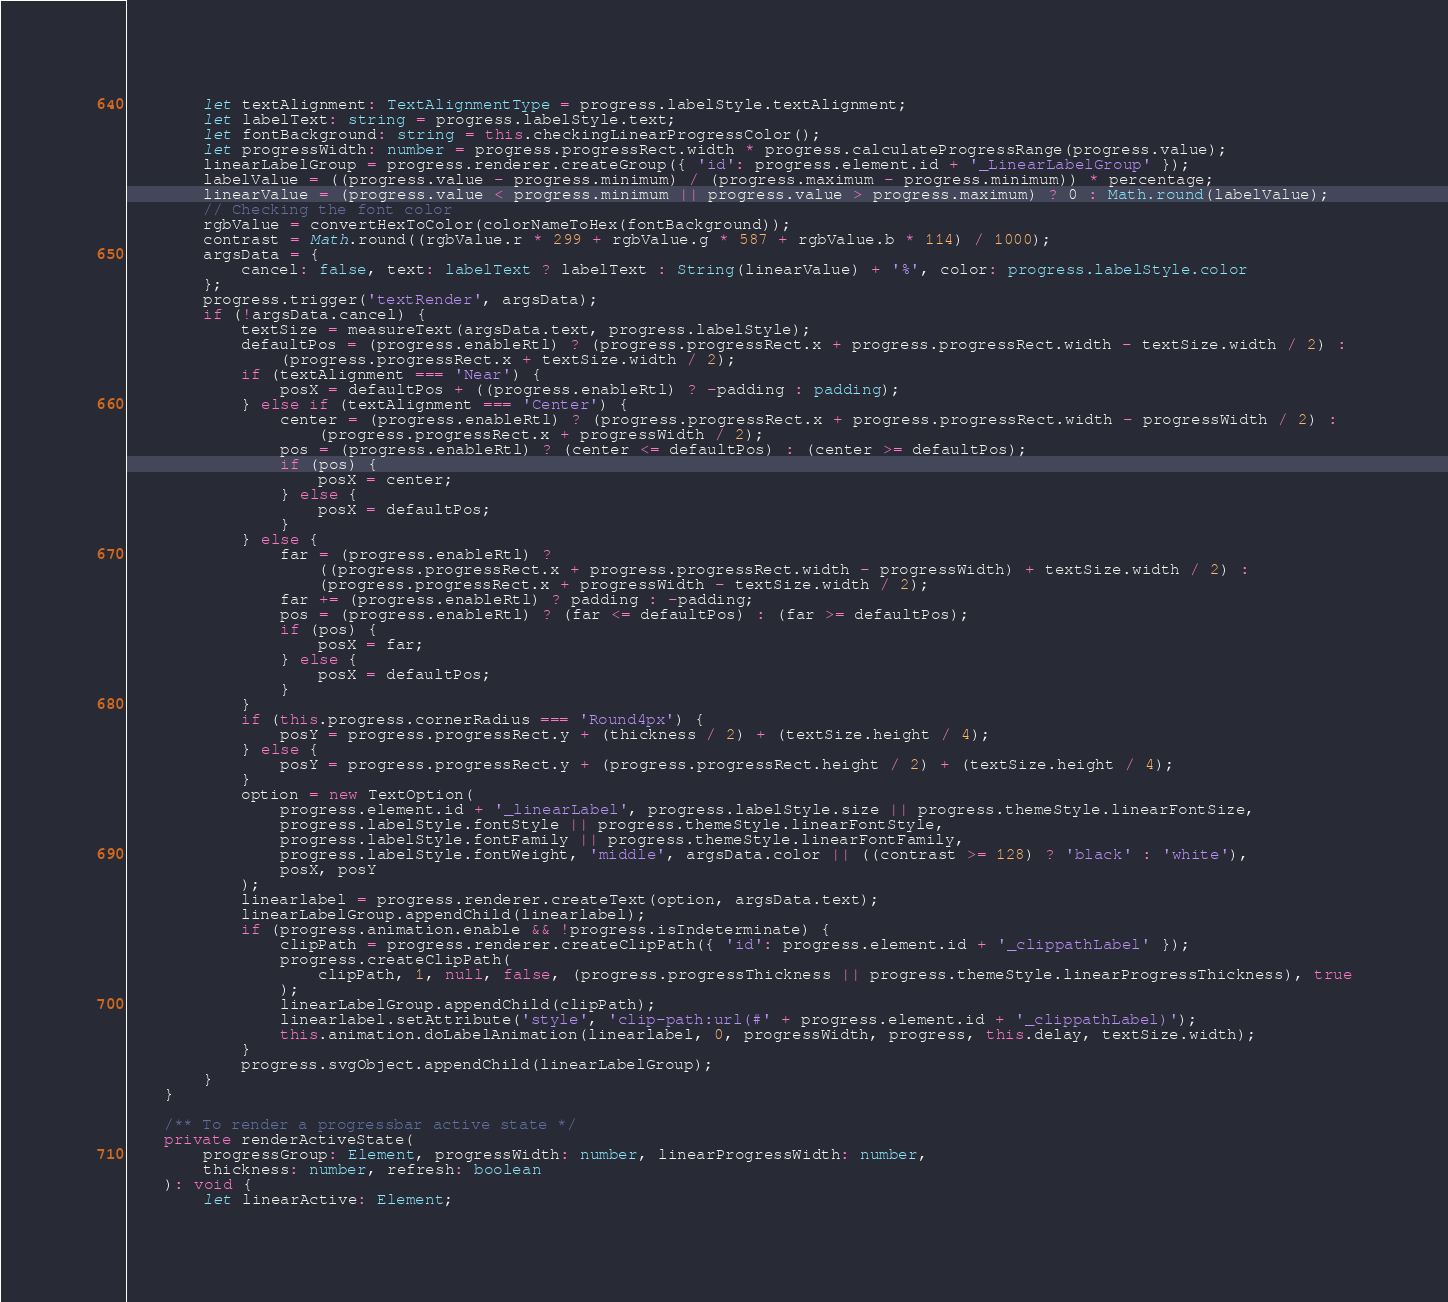Convert code to text. <code><loc_0><loc_0><loc_500><loc_500><_TypeScript_>        let textAlignment: TextAlignmentType = progress.labelStyle.textAlignment;
        let labelText: string = progress.labelStyle.text;
        let fontBackground: string = this.checkingLinearProgressColor();
        let progressWidth: number = progress.progressRect.width * progress.calculateProgressRange(progress.value);
        linearLabelGroup = progress.renderer.createGroup({ 'id': progress.element.id + '_LinearLabelGroup' });
        labelValue = ((progress.value - progress.minimum) / (progress.maximum - progress.minimum)) * percentage;
        linearValue = (progress.value < progress.minimum || progress.value > progress.maximum) ? 0 : Math.round(labelValue);
        // Checking the font color
        rgbValue = convertHexToColor(colorNameToHex(fontBackground));
        contrast = Math.round((rgbValue.r * 299 + rgbValue.g * 587 + rgbValue.b * 114) / 1000);
        argsData = {
            cancel: false, text: labelText ? labelText : String(linearValue) + '%', color: progress.labelStyle.color
        };
        progress.trigger('textRender', argsData);
        if (!argsData.cancel) {
            textSize = measureText(argsData.text, progress.labelStyle);
            defaultPos = (progress.enableRtl) ? (progress.progressRect.x + progress.progressRect.width - textSize.width / 2) :
                (progress.progressRect.x + textSize.width / 2);
            if (textAlignment === 'Near') {
                posX = defaultPos + ((progress.enableRtl) ? -padding : padding);
            } else if (textAlignment === 'Center') {
                center = (progress.enableRtl) ? (progress.progressRect.x + progress.progressRect.width - progressWidth / 2) :
                    (progress.progressRect.x + progressWidth / 2);
                pos = (progress.enableRtl) ? (center <= defaultPos) : (center >= defaultPos);
                if (pos) {
                    posX = center;
                } else {
                    posX = defaultPos;
                }
            } else {
                far = (progress.enableRtl) ?
                    ((progress.progressRect.x + progress.progressRect.width - progressWidth) + textSize.width / 2) :
                    (progress.progressRect.x + progressWidth - textSize.width / 2);
                far += (progress.enableRtl) ? padding : -padding;
                pos = (progress.enableRtl) ? (far <= defaultPos) : (far >= defaultPos);
                if (pos) {
                    posX = far;
                } else {
                    posX = defaultPos;
                }
            }
            if (this.progress.cornerRadius === 'Round4px') {
                posY = progress.progressRect.y + (thickness / 2) + (textSize.height / 4);
            } else {
                posY = progress.progressRect.y + (progress.progressRect.height / 2) + (textSize.height / 4);
            }
            option = new TextOption(
                progress.element.id + '_linearLabel', progress.labelStyle.size || progress.themeStyle.linearFontSize,
                progress.labelStyle.fontStyle || progress.themeStyle.linearFontStyle,
                progress.labelStyle.fontFamily || progress.themeStyle.linearFontFamily,
                progress.labelStyle.fontWeight, 'middle', argsData.color || ((contrast >= 128) ? 'black' : 'white'),
                posX, posY
            );
            linearlabel = progress.renderer.createText(option, argsData.text);
            linearLabelGroup.appendChild(linearlabel);
            if (progress.animation.enable && !progress.isIndeterminate) {
                clipPath = progress.renderer.createClipPath({ 'id': progress.element.id + '_clippathLabel' });
                progress.createClipPath(
                    clipPath, 1, null, false, (progress.progressThickness || progress.themeStyle.linearProgressThickness), true
                );
                linearLabelGroup.appendChild(clipPath);
                linearlabel.setAttribute('style', 'clip-path:url(#' + progress.element.id + '_clippathLabel)');
                this.animation.doLabelAnimation(linearlabel, 0, progressWidth, progress, this.delay, textSize.width);
            }
            progress.svgObject.appendChild(linearLabelGroup);
        }
    }

    /** To render a progressbar active state */
    private renderActiveState(
        progressGroup: Element, progressWidth: number, linearProgressWidth: number,
        thickness: number, refresh: boolean
    ): void {
        let linearActive: Element;</code> 